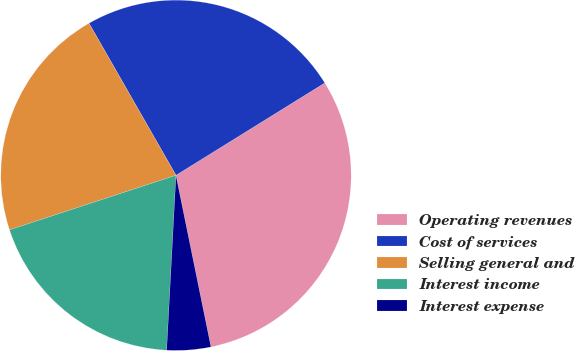Convert chart. <chart><loc_0><loc_0><loc_500><loc_500><pie_chart><fcel>Operating revenues<fcel>Cost of services<fcel>Selling general and<fcel>Interest income<fcel>Interest expense<nl><fcel>30.64%<fcel>24.43%<fcel>21.77%<fcel>19.11%<fcel>4.05%<nl></chart> 